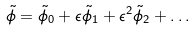Convert formula to latex. <formula><loc_0><loc_0><loc_500><loc_500>\tilde { \phi } = \tilde { \phi } _ { 0 } + \epsilon \tilde { \phi } _ { 1 } + \epsilon ^ { 2 } \tilde { \phi } _ { 2 } + \dots</formula> 